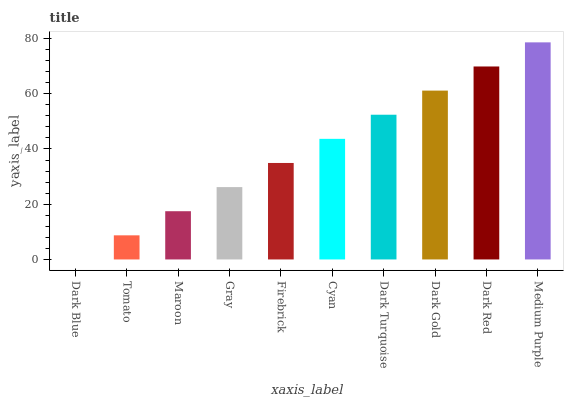Is Dark Blue the minimum?
Answer yes or no. Yes. Is Medium Purple the maximum?
Answer yes or no. Yes. Is Tomato the minimum?
Answer yes or no. No. Is Tomato the maximum?
Answer yes or no. No. Is Tomato greater than Dark Blue?
Answer yes or no. Yes. Is Dark Blue less than Tomato?
Answer yes or no. Yes. Is Dark Blue greater than Tomato?
Answer yes or no. No. Is Tomato less than Dark Blue?
Answer yes or no. No. Is Cyan the high median?
Answer yes or no. Yes. Is Firebrick the low median?
Answer yes or no. Yes. Is Gray the high median?
Answer yes or no. No. Is Cyan the low median?
Answer yes or no. No. 